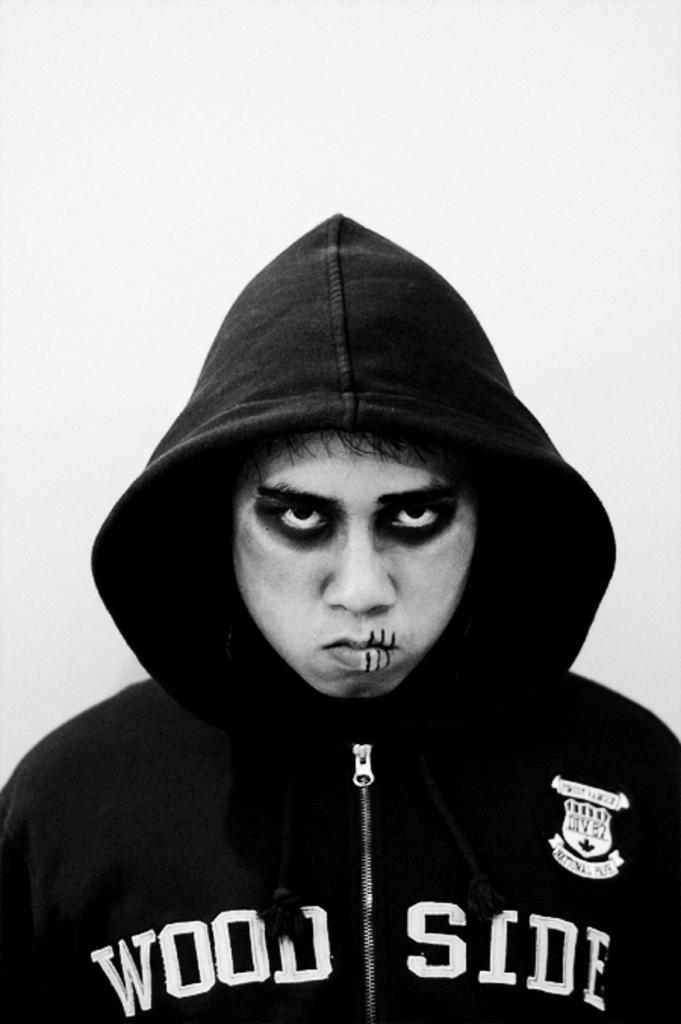Who or what is present in the image? There is a person in the image. What is the person wearing? The person is wearing a jacket. What color is the background of the image? The background of the image is white. What appliance is causing trouble for the person in the image? There is no appliance present in the image, nor is there any indication of trouble for the person. 